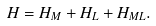<formula> <loc_0><loc_0><loc_500><loc_500>H = H _ { M } + H _ { L } + H _ { M L } .</formula> 